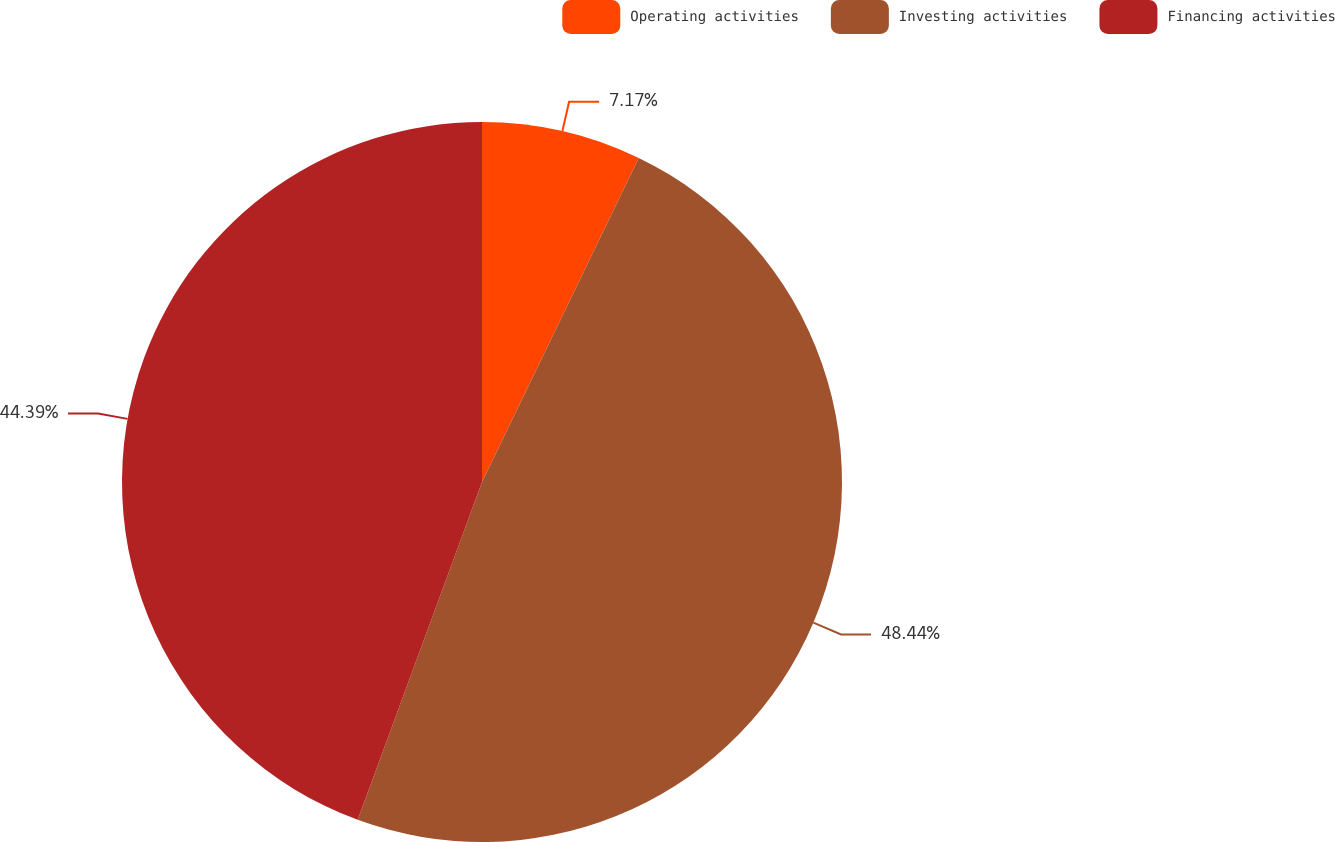Convert chart. <chart><loc_0><loc_0><loc_500><loc_500><pie_chart><fcel>Operating activities<fcel>Investing activities<fcel>Financing activities<nl><fcel>7.17%<fcel>48.44%<fcel>44.39%<nl></chart> 